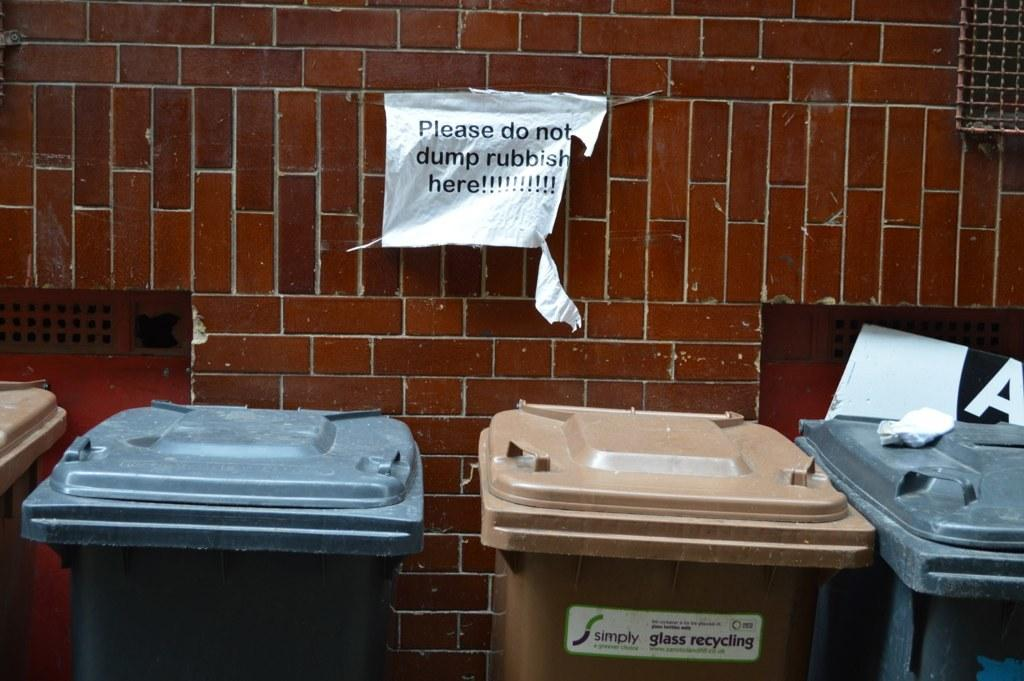<image>
Render a clear and concise summary of the photo. A row of trash cans outside a brick building with a sign saying Please do not dump rubish here. 